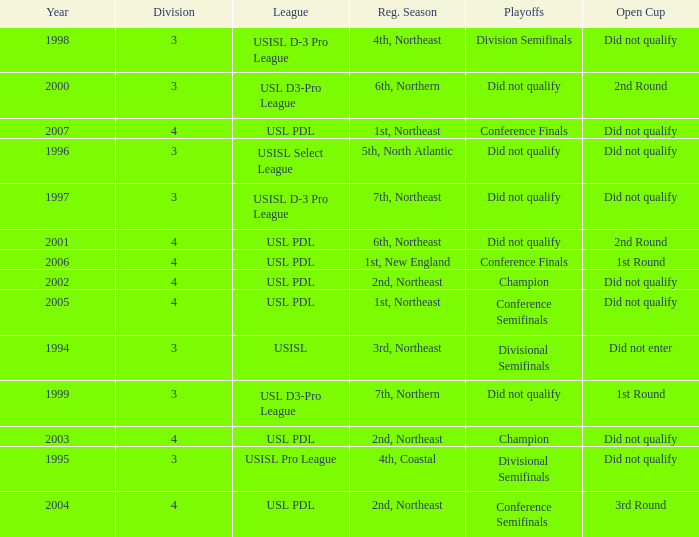Name the league for 2003 USL PDL. 